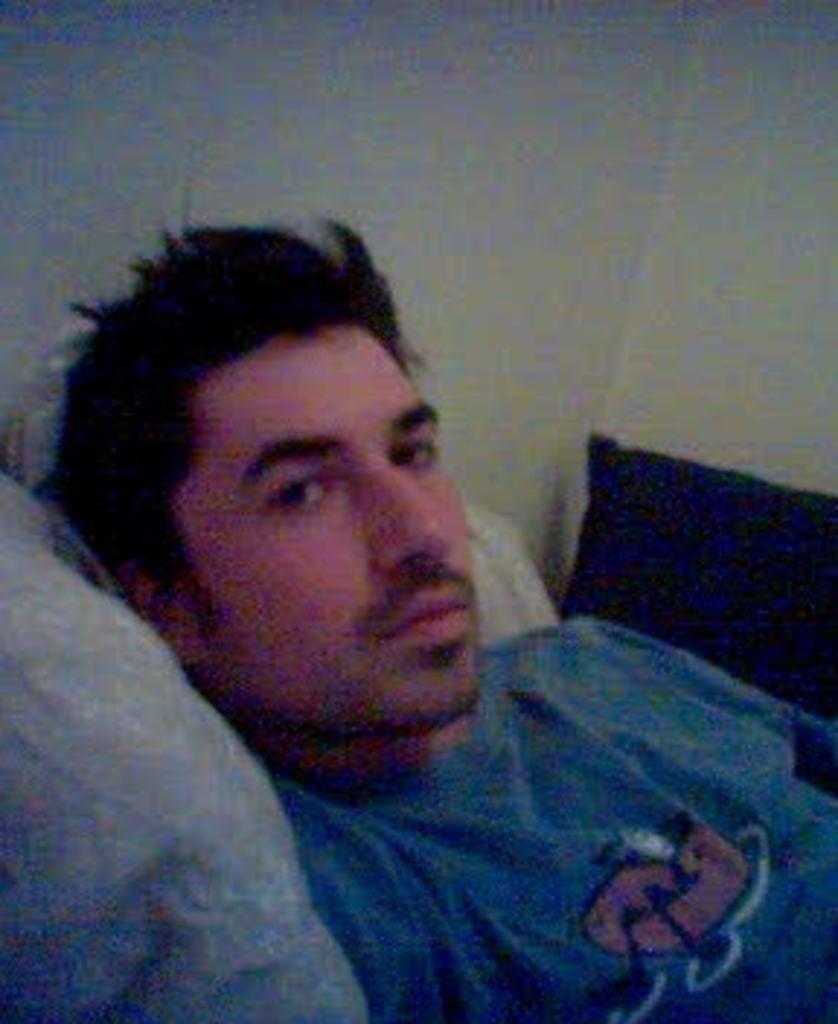Could you give a brief overview of what you see in this image? In this picture we can see a man. There are pillows. In the background we can see wall. 